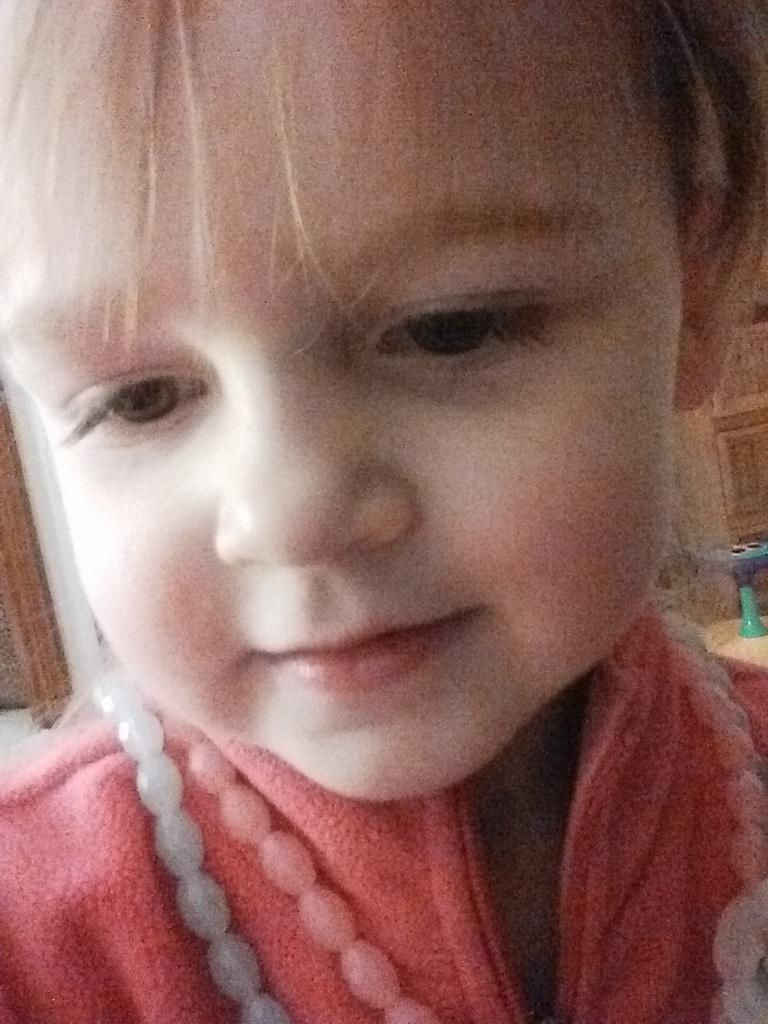What is the main subject of the image? The main subject of the image is a kid. What is the kid wearing in the image? The kid is wearing a red shirt. What can be seen in the background of the image? There is a door in the background of the image. How many lizards can be seen crawling on the kid's knee in the image? There are no lizards present in the image, and therefore no such activity can be observed. 